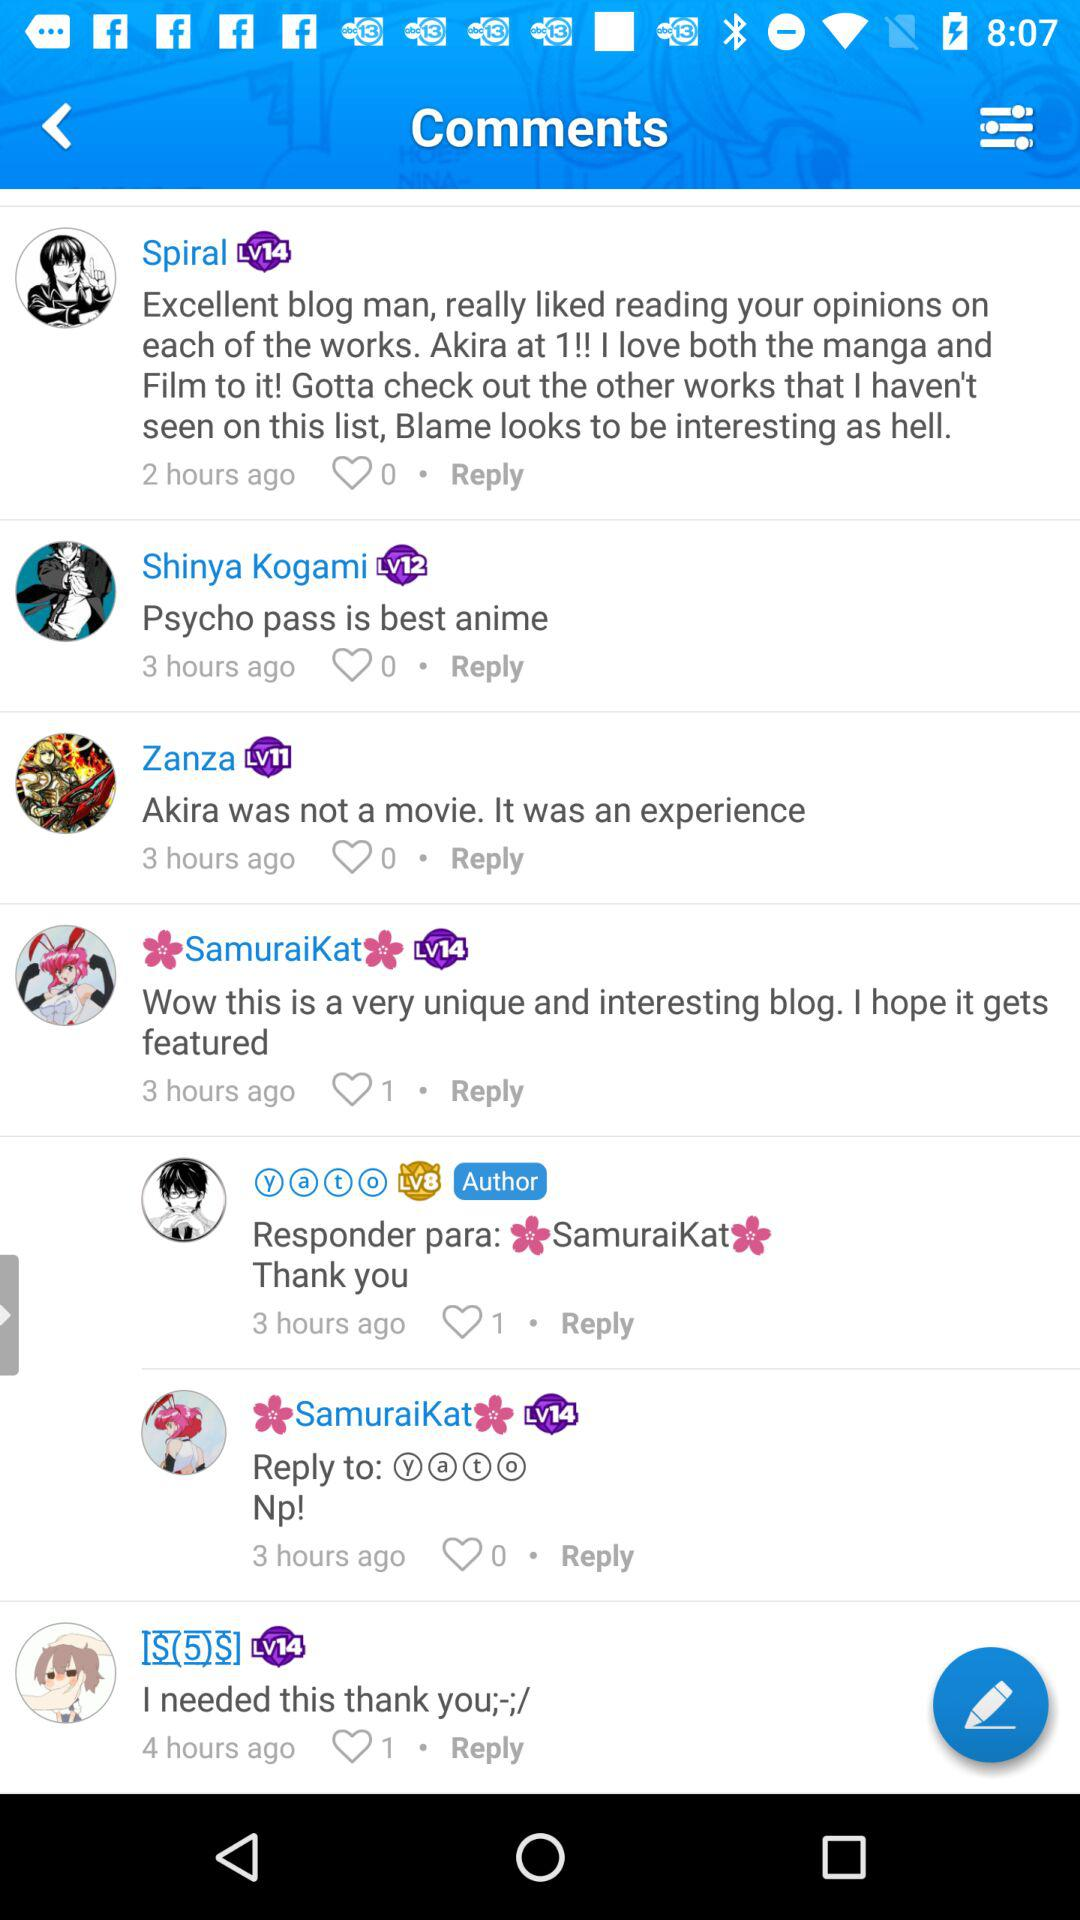When did Zanza comment? Zanza commented 3 hours ago. 